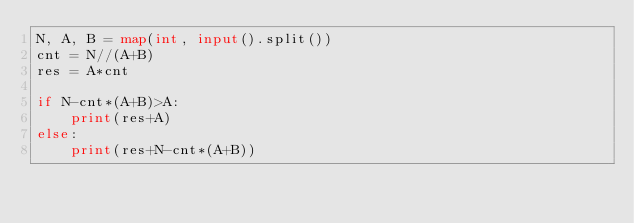<code> <loc_0><loc_0><loc_500><loc_500><_Python_>N, A, B = map(int, input().split())
cnt = N//(A+B)
res = A*cnt

if N-cnt*(A+B)>A:
    print(res+A)
else:
    print(res+N-cnt*(A+B))</code> 